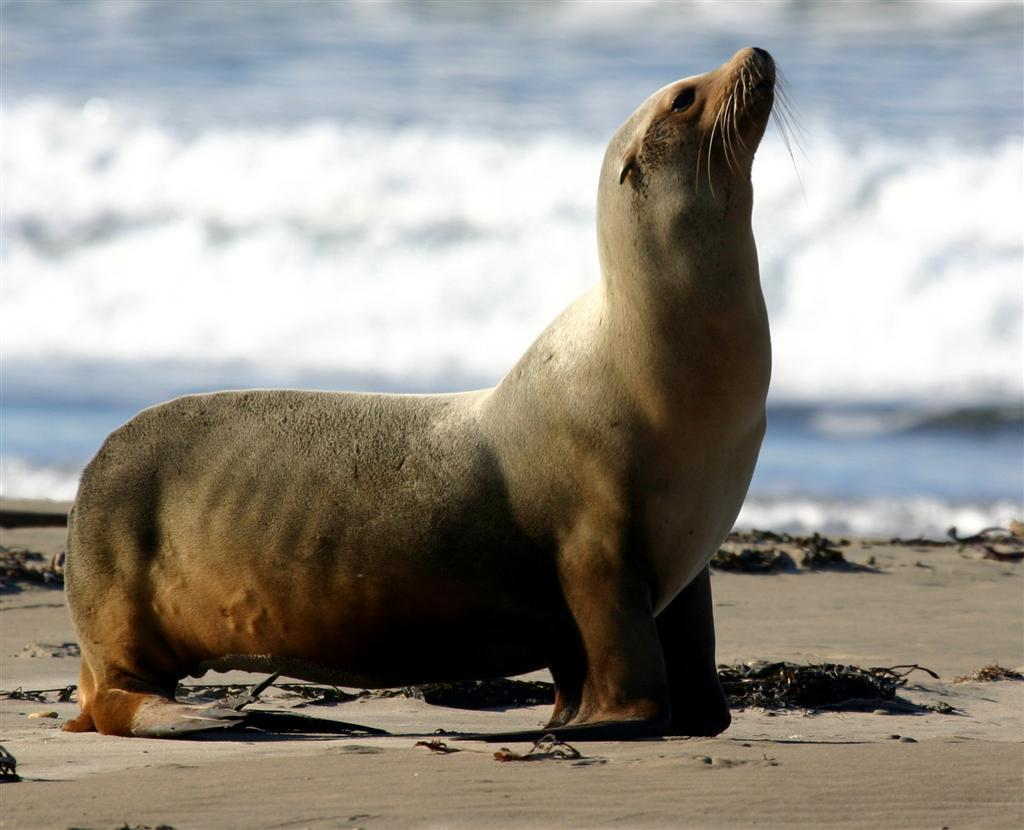What type of animal is in the image? There is a sea lion in the image. Where is the sea lion located? The sea lion is on the sand. What can be seen in the background behind the sea lion? There is water visible behind the sea lion. How many cacti are present in the image? There are no cacti present in the image; it features a sea lion on the sand with water visible in the background. 